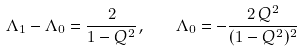Convert formula to latex. <formula><loc_0><loc_0><loc_500><loc_500>\Lambda _ { 1 } - \Lambda _ { 0 } = \frac { 2 } { 1 - Q ^ { 2 } } , \quad \Lambda _ { 0 } = - \frac { 2 \, Q ^ { 2 } } { ( 1 - Q ^ { 2 } ) ^ { 2 } }</formula> 